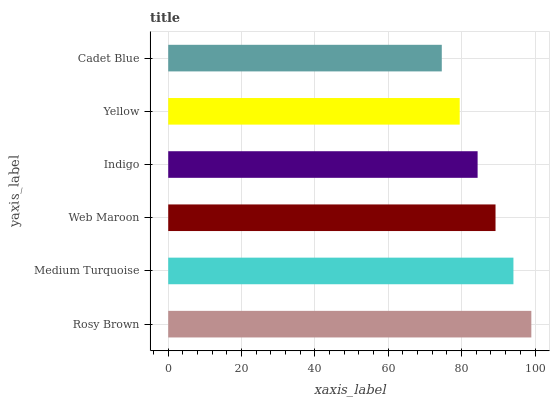Is Cadet Blue the minimum?
Answer yes or no. Yes. Is Rosy Brown the maximum?
Answer yes or no. Yes. Is Medium Turquoise the minimum?
Answer yes or no. No. Is Medium Turquoise the maximum?
Answer yes or no. No. Is Rosy Brown greater than Medium Turquoise?
Answer yes or no. Yes. Is Medium Turquoise less than Rosy Brown?
Answer yes or no. Yes. Is Medium Turquoise greater than Rosy Brown?
Answer yes or no. No. Is Rosy Brown less than Medium Turquoise?
Answer yes or no. No. Is Web Maroon the high median?
Answer yes or no. Yes. Is Indigo the low median?
Answer yes or no. Yes. Is Cadet Blue the high median?
Answer yes or no. No. Is Yellow the low median?
Answer yes or no. No. 